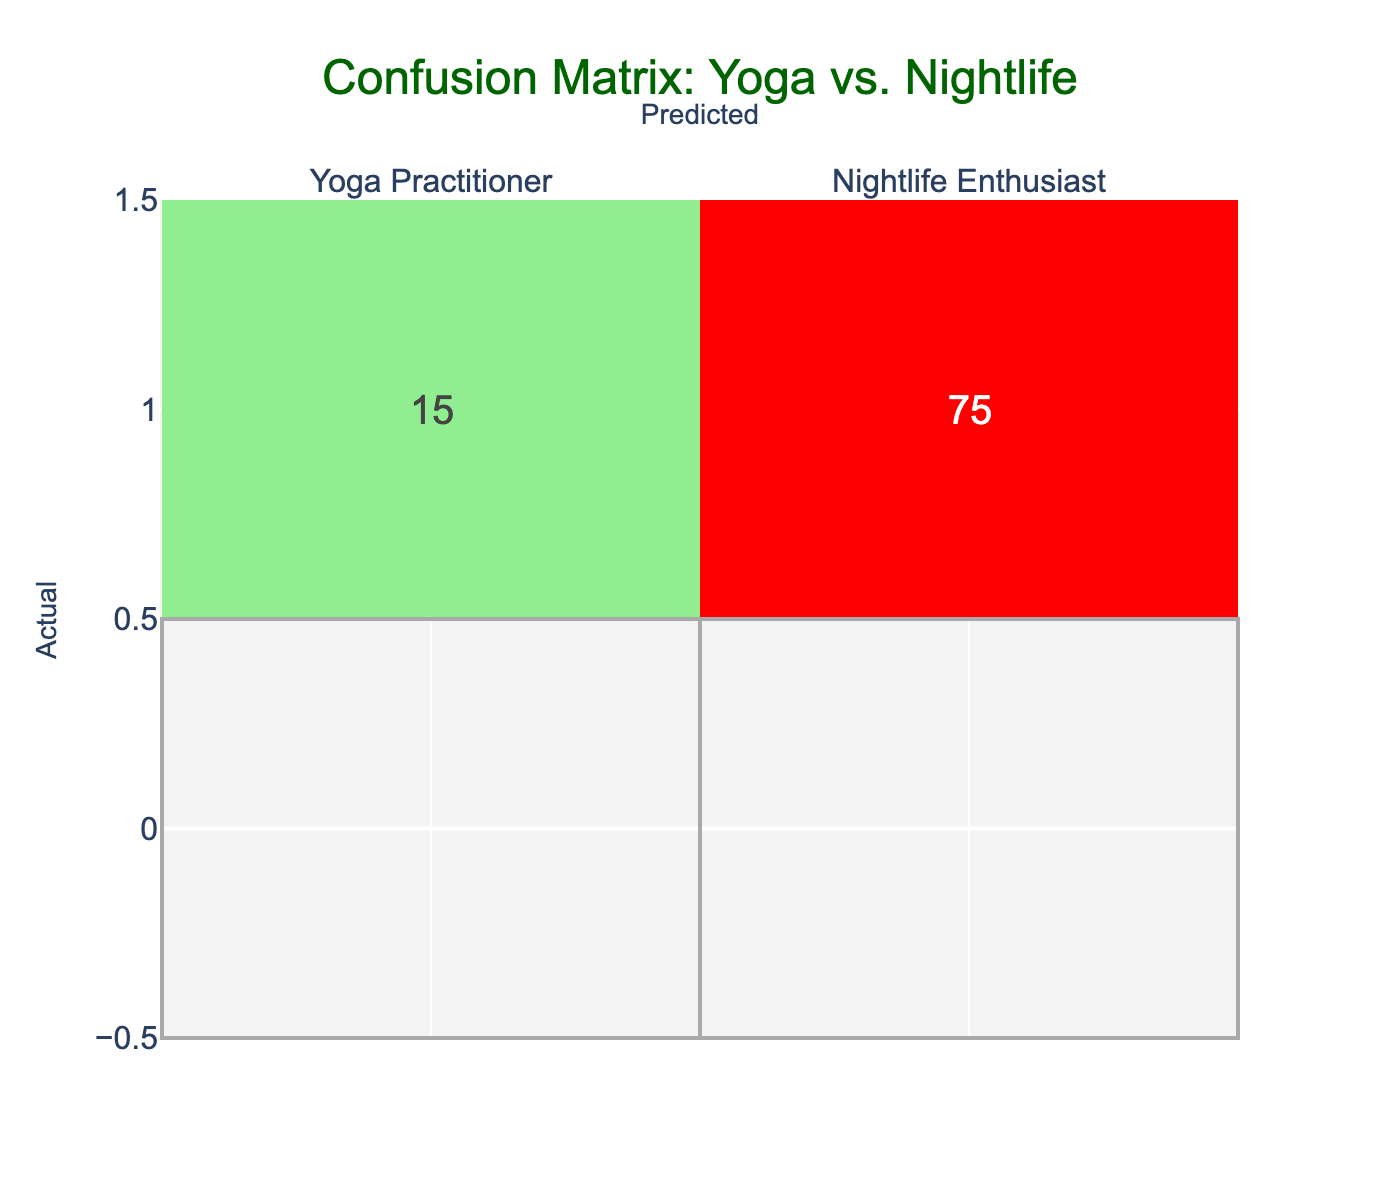What is the number of yoga practitioners correctly predicted? From the confusion matrix, the cell representing yoga practitioners correctly predicted is 80. This value is found in the intersection of the "Yoga Practitioner" row and the "Yoga Practitioner" column.
Answer: 80 What is the number of nightlife enthusiasts misclassified as yoga practitioners? The value in the cell for nightlife enthusiasts predicted to be yoga practitioners is 15. This is located in the "Nightlife Enthusiast" row and the "Yoga Practitioner" column.
Answer: 15 What percentage of actual yoga practitioners were correctly predicted? To find this percentage, we take the number of correctly predicted yoga practitioners (80), divide it by the total actual yoga practitioners (80 + 10 = 90), and then multiply by 100. Thus, (80/90) * 100 = 88.89%.
Answer: 88.89% What is the total number of nightlife enthusiasts in the data? The total number of nightlife enthusiasts is the sum of the correctly classified plus misclassified values: 75 (correct) + 15 (misclassified) = 90.
Answer: 90 Is the number of yoga practitioners misclassified higher than that of nightlife enthusiasts misclassified? Yes, the number of yoga practitioners misclassified is 10, while the number of nightlife enthusiasts misclassified is 15. Therefore, 10 is not higher than 15.
Answer: No What is the overall accuracy of the predictions in the confusion matrix? The overall accuracy can be found by summing the true positives (80 + 75) and dividing by the total predictions (80 + 10 + 15 + 75 = 180). Thus, the calculation is (80 + 75) / 180 = 155 / 180 = 0.8611 or approximately 86.11%.
Answer: 86.11% What is the difference in the number of yoga practitioners and nightlife enthusiasts who were correctly predicted? To find the difference, we subtract the number of correctly predicted nightlife enthusiasts (75) from the number of correctly predicted yoga practitioners (80). Therefore, 80 - 75 = 5.
Answer: 5 How many total students were evaluated in this confusion matrix? The total number of students evaluated is the sum of all values in the confusion matrix: 80 (correct yoga) + 10 (misclassified yoga) + 15 (misclassified nightlife) + 75 (correct nightlife) = 180.
Answer: 180 